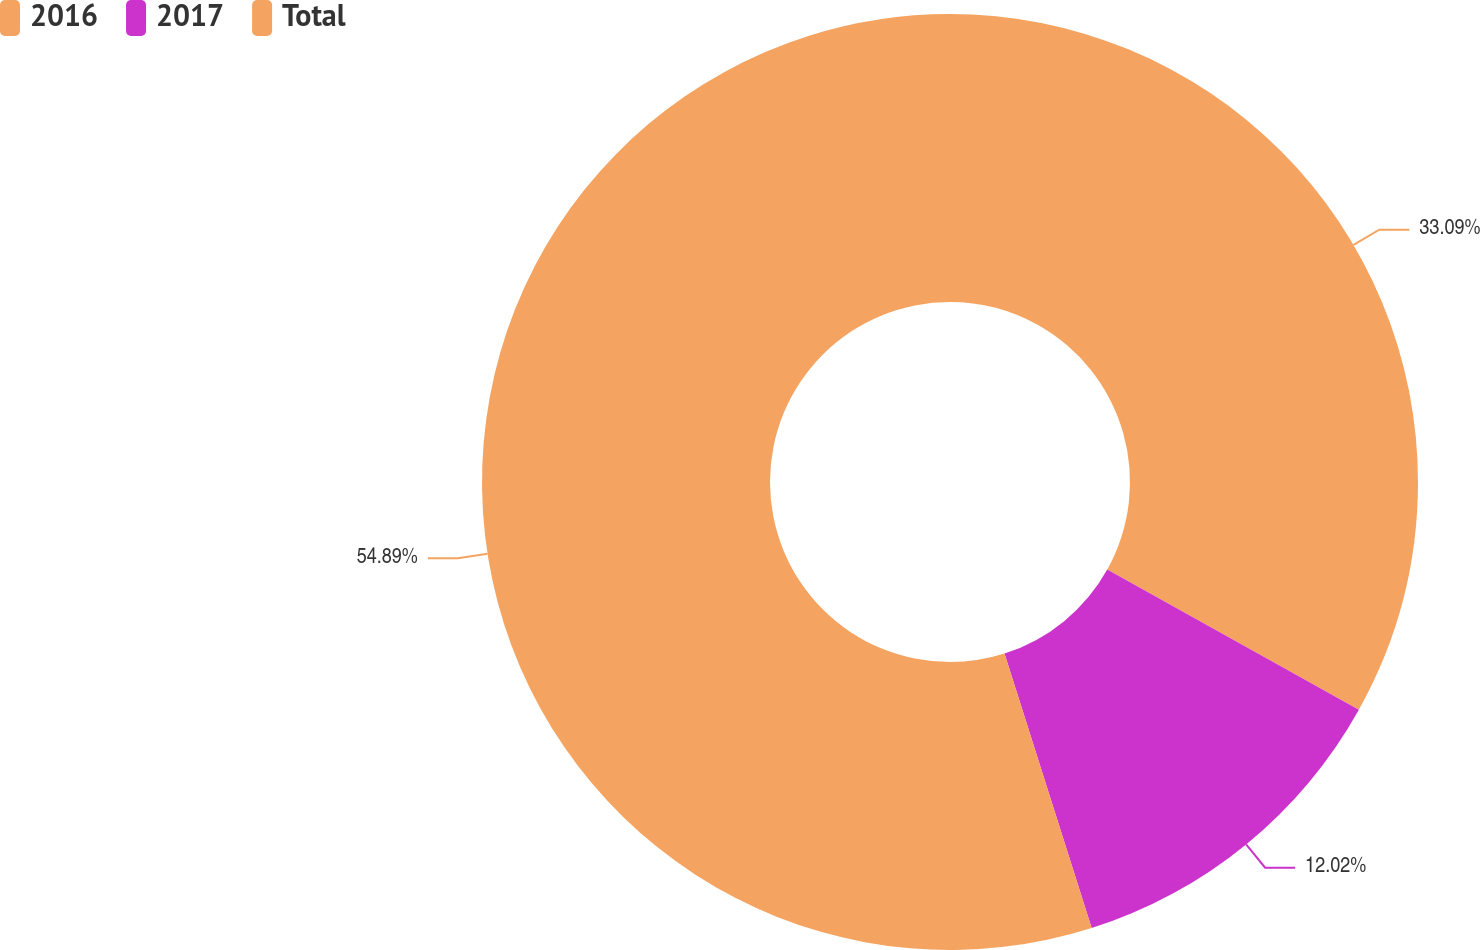Convert chart. <chart><loc_0><loc_0><loc_500><loc_500><pie_chart><fcel>2016<fcel>2017<fcel>Total<nl><fcel>33.09%<fcel>12.02%<fcel>54.9%<nl></chart> 